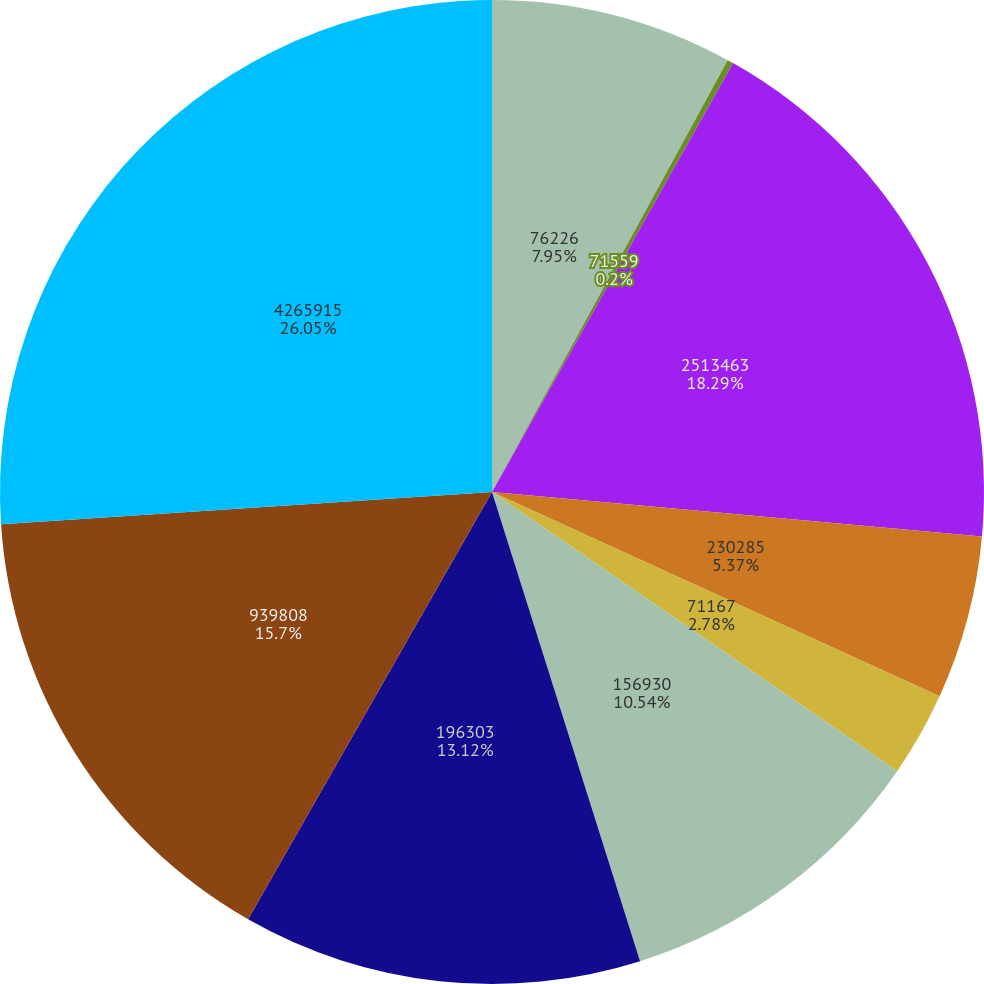Convert chart. <chart><loc_0><loc_0><loc_500><loc_500><pie_chart><fcel>76226<fcel>71559<fcel>2513463<fcel>230285<fcel>71167<fcel>156930<fcel>196303<fcel>939808<fcel>4265915<nl><fcel>7.95%<fcel>0.2%<fcel>18.29%<fcel>5.37%<fcel>2.78%<fcel>10.54%<fcel>13.12%<fcel>15.7%<fcel>26.04%<nl></chart> 